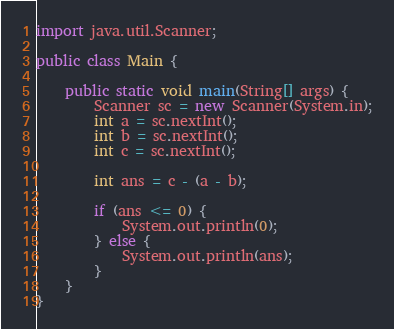Convert code to text. <code><loc_0><loc_0><loc_500><loc_500><_Java_>
import java.util.Scanner;

public class Main {

	public static void main(String[] args) {
		Scanner sc = new Scanner(System.in);
		int a = sc.nextInt();
		int b = sc.nextInt();
		int c = sc.nextInt();

		int ans = c - (a - b);

		if (ans <= 0) {
			System.out.println(0);
		} else {
			System.out.println(ans);
		}
	}
}</code> 